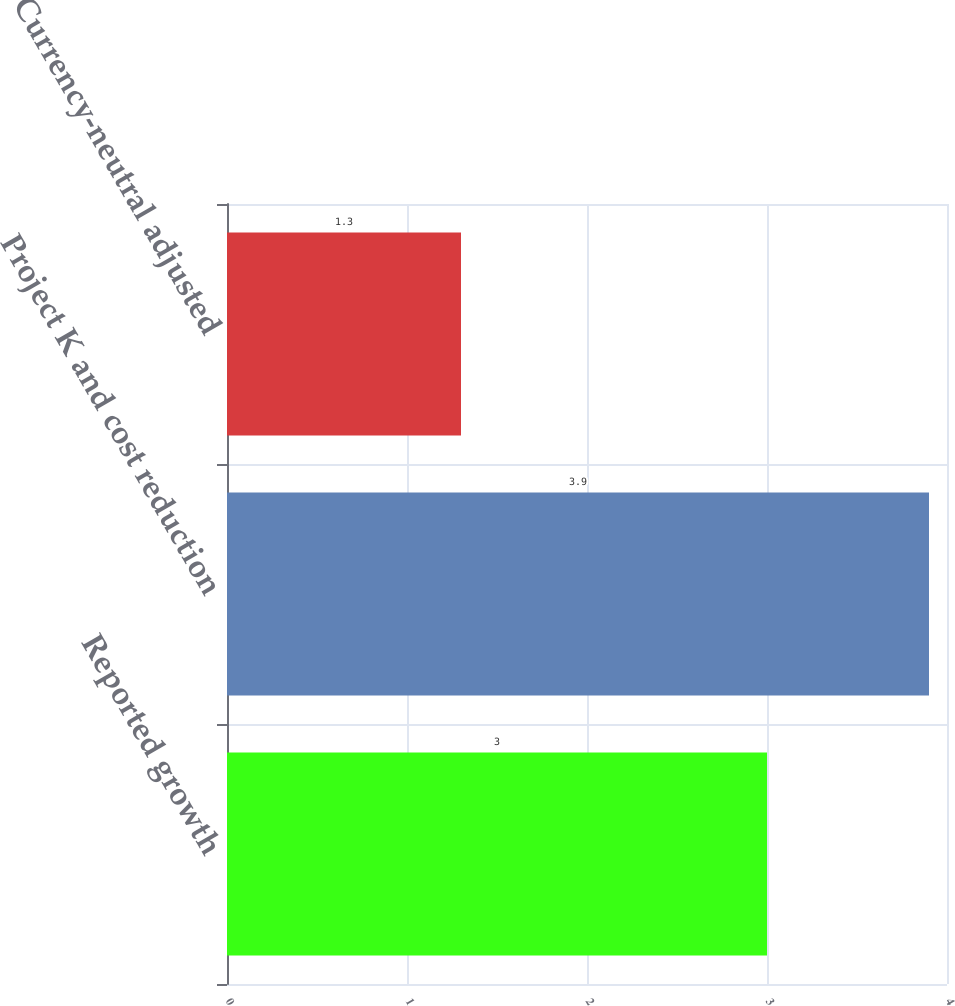Convert chart. <chart><loc_0><loc_0><loc_500><loc_500><bar_chart><fcel>Reported growth<fcel>Project K and cost reduction<fcel>Currency-neutral adjusted<nl><fcel>3<fcel>3.9<fcel>1.3<nl></chart> 